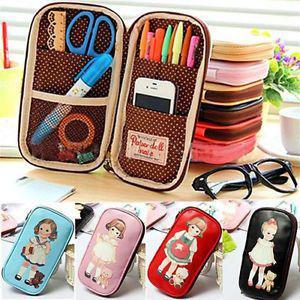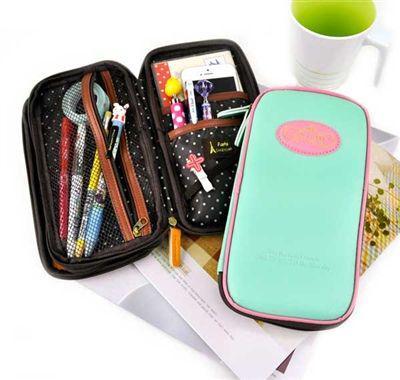The first image is the image on the left, the second image is the image on the right. For the images displayed, is the sentence "The left image includes a pair of eyeglasses at least partly visible." factually correct? Answer yes or no. Yes. 